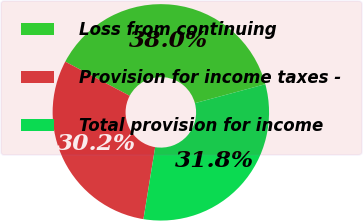Convert chart. <chart><loc_0><loc_0><loc_500><loc_500><pie_chart><fcel>Loss from continuing<fcel>Provision for income taxes -<fcel>Total provision for income<nl><fcel>38.05%<fcel>30.19%<fcel>31.76%<nl></chart> 